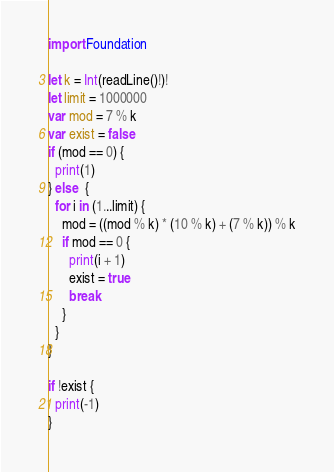<code> <loc_0><loc_0><loc_500><loc_500><_Swift_>import Foundation

let k = Int(readLine()!)!
let limit = 1000000
var mod = 7 % k
var exist = false
if (mod == 0) {
  print(1)
} else  {
  for i in (1...limit) {
  	mod = ((mod % k) * (10 % k) + (7 % k)) % k
    if mod == 0 {
      print(i + 1)
      exist = true
      break
    }
  }
}

if !exist {
  print(-1)
}</code> 